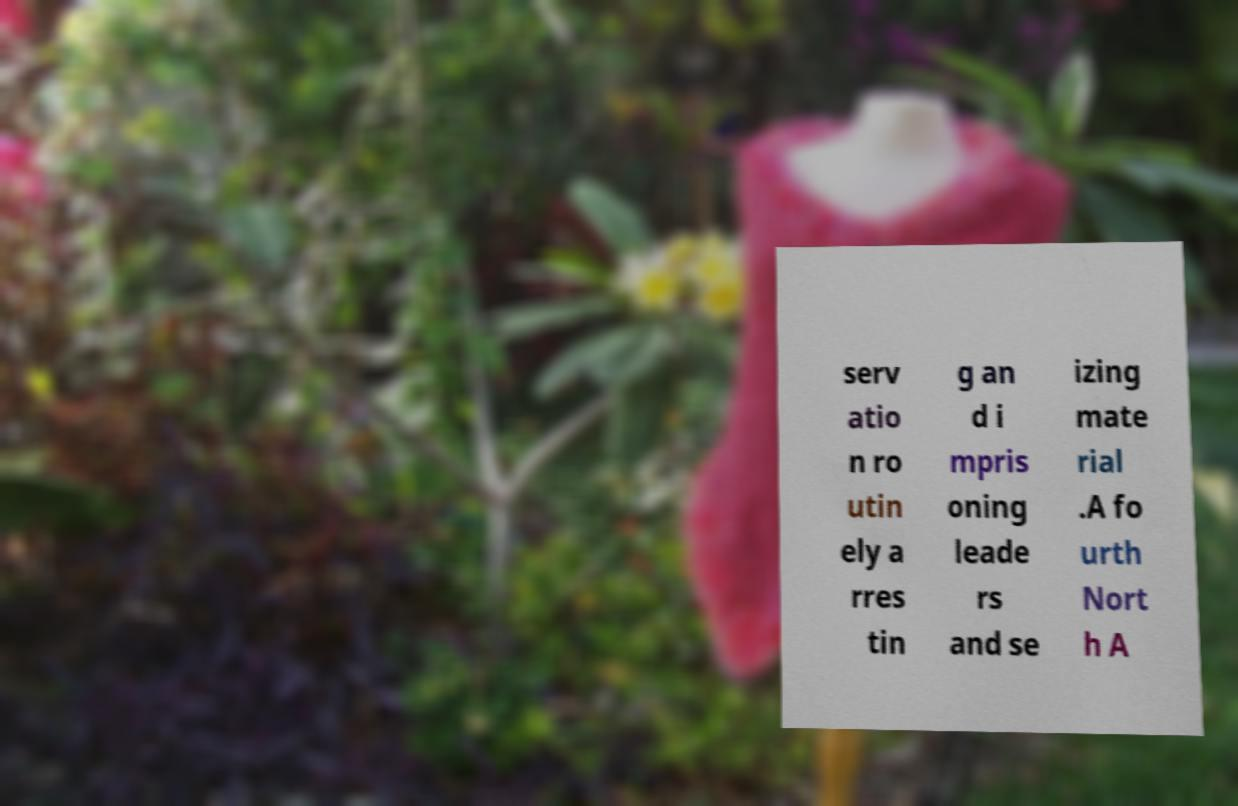What messages or text are displayed in this image? I need them in a readable, typed format. serv atio n ro utin ely a rres tin g an d i mpris oning leade rs and se izing mate rial .A fo urth Nort h A 